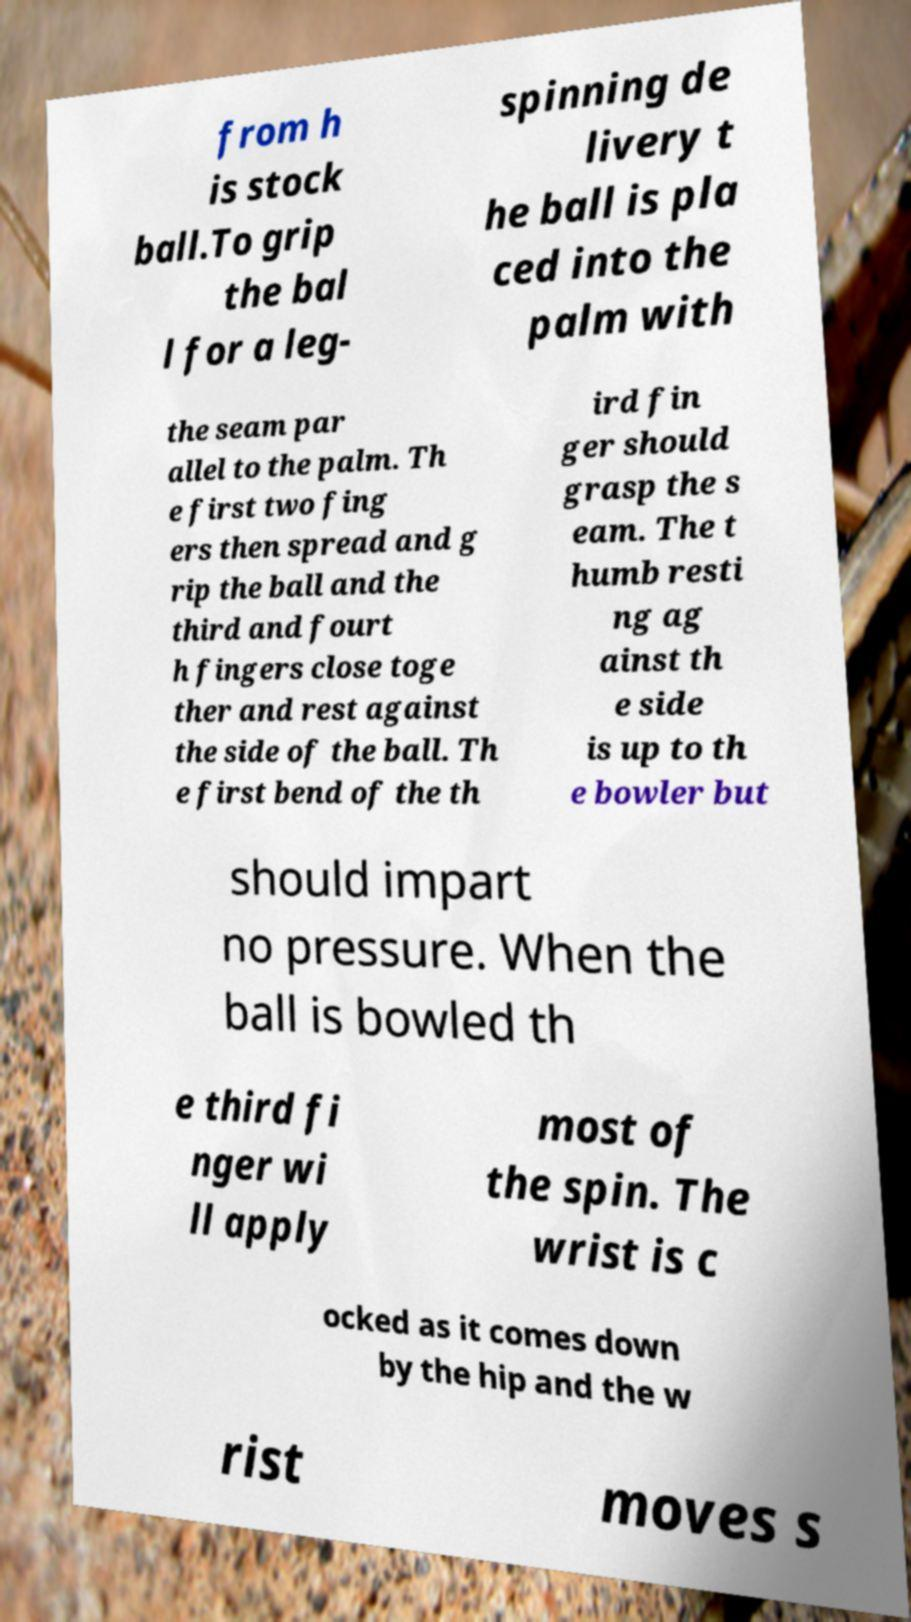Can you accurately transcribe the text from the provided image for me? from h is stock ball.To grip the bal l for a leg- spinning de livery t he ball is pla ced into the palm with the seam par allel to the palm. Th e first two fing ers then spread and g rip the ball and the third and fourt h fingers close toge ther and rest against the side of the ball. Th e first bend of the th ird fin ger should grasp the s eam. The t humb resti ng ag ainst th e side is up to th e bowler but should impart no pressure. When the ball is bowled th e third fi nger wi ll apply most of the spin. The wrist is c ocked as it comes down by the hip and the w rist moves s 